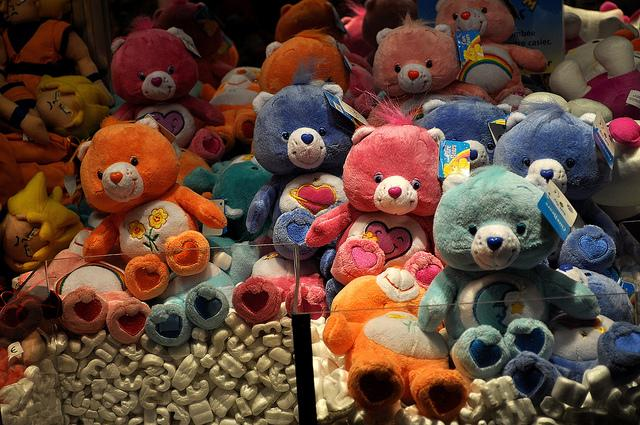What are the small white objects below the stuffed animals?

Choices:
A) erasers
B) packing peanuts
C) balls
D) clips packing peanuts 